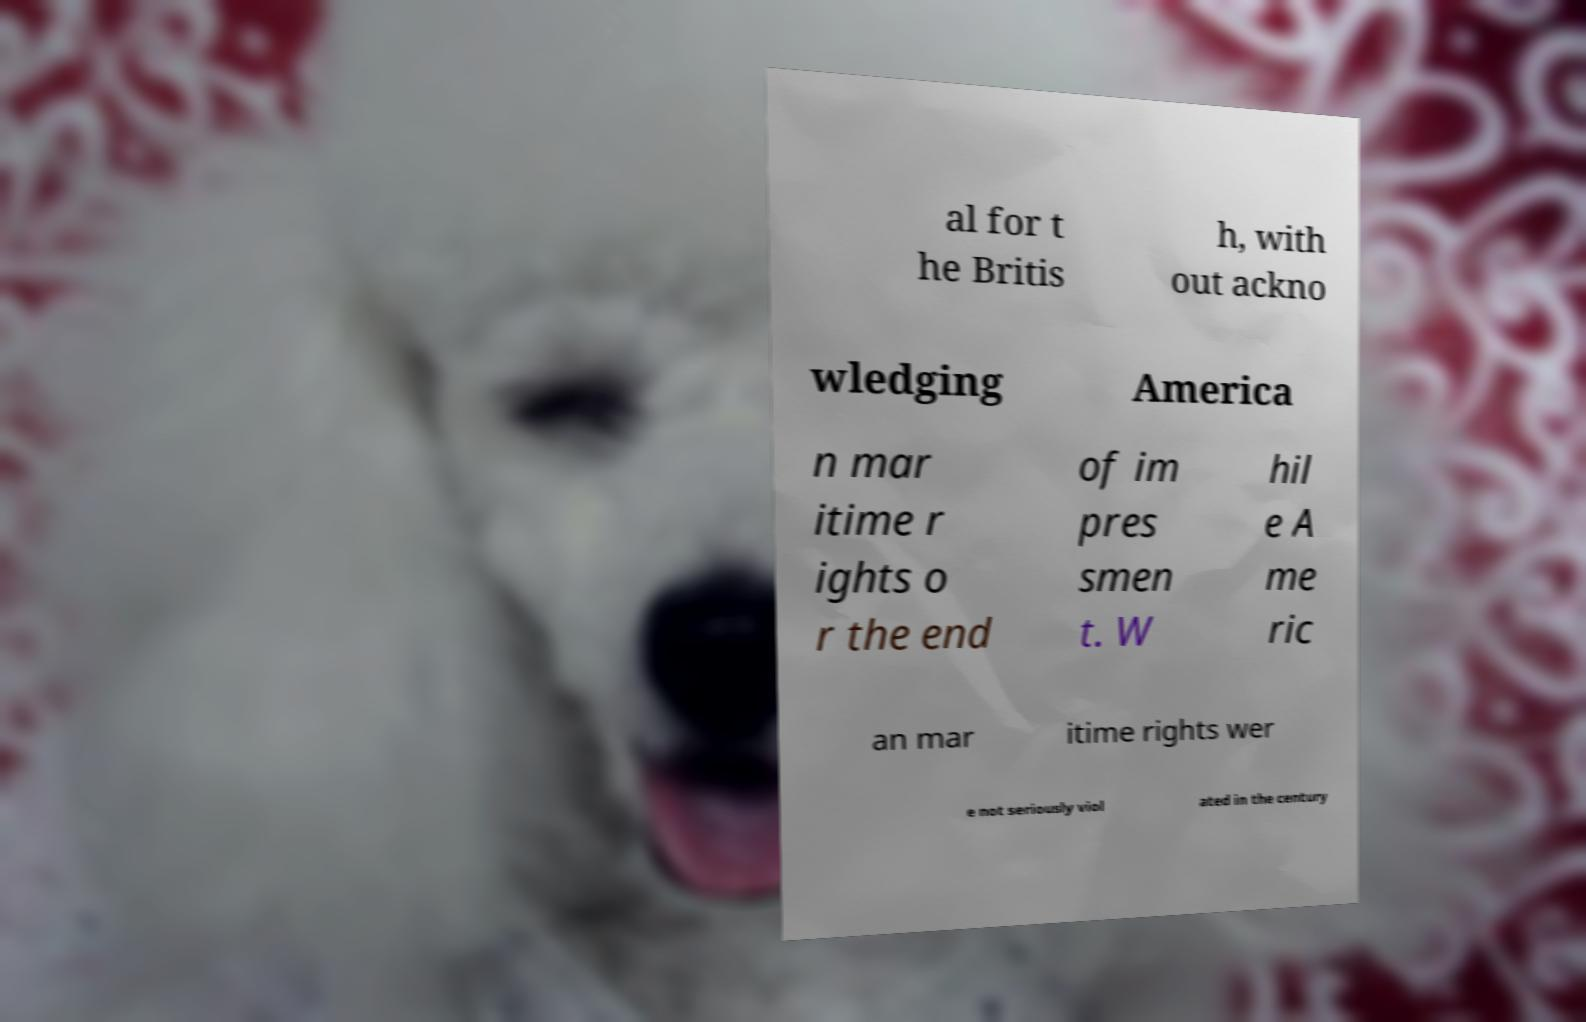I need the written content from this picture converted into text. Can you do that? al for t he Britis h, with out ackno wledging America n mar itime r ights o r the end of im pres smen t. W hil e A me ric an mar itime rights wer e not seriously viol ated in the century 